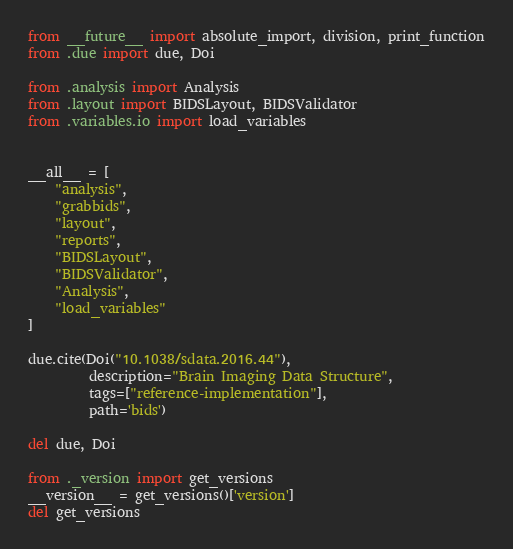<code> <loc_0><loc_0><loc_500><loc_500><_Python_>from __future__ import absolute_import, division, print_function
from .due import due, Doi

from .analysis import Analysis
from .layout import BIDSLayout, BIDSValidator
from .variables.io import load_variables


__all__ = [
    "analysis",
    "grabbids",
    "layout",
    "reports",
    "BIDSLayout",
    "BIDSValidator",
    "Analysis",
    "load_variables"
]

due.cite(Doi("10.1038/sdata.2016.44"),
         description="Brain Imaging Data Structure",
         tags=["reference-implementation"],
         path='bids')

del due, Doi

from ._version import get_versions
__version__ = get_versions()['version']
del get_versions
</code> 